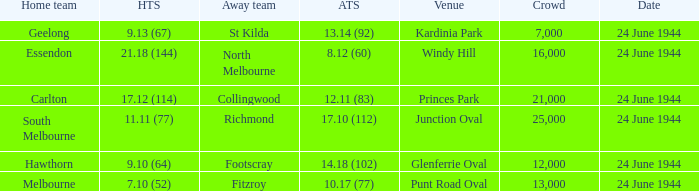When the Crowd was larger than 25,000. what was the Home Team score? None. 